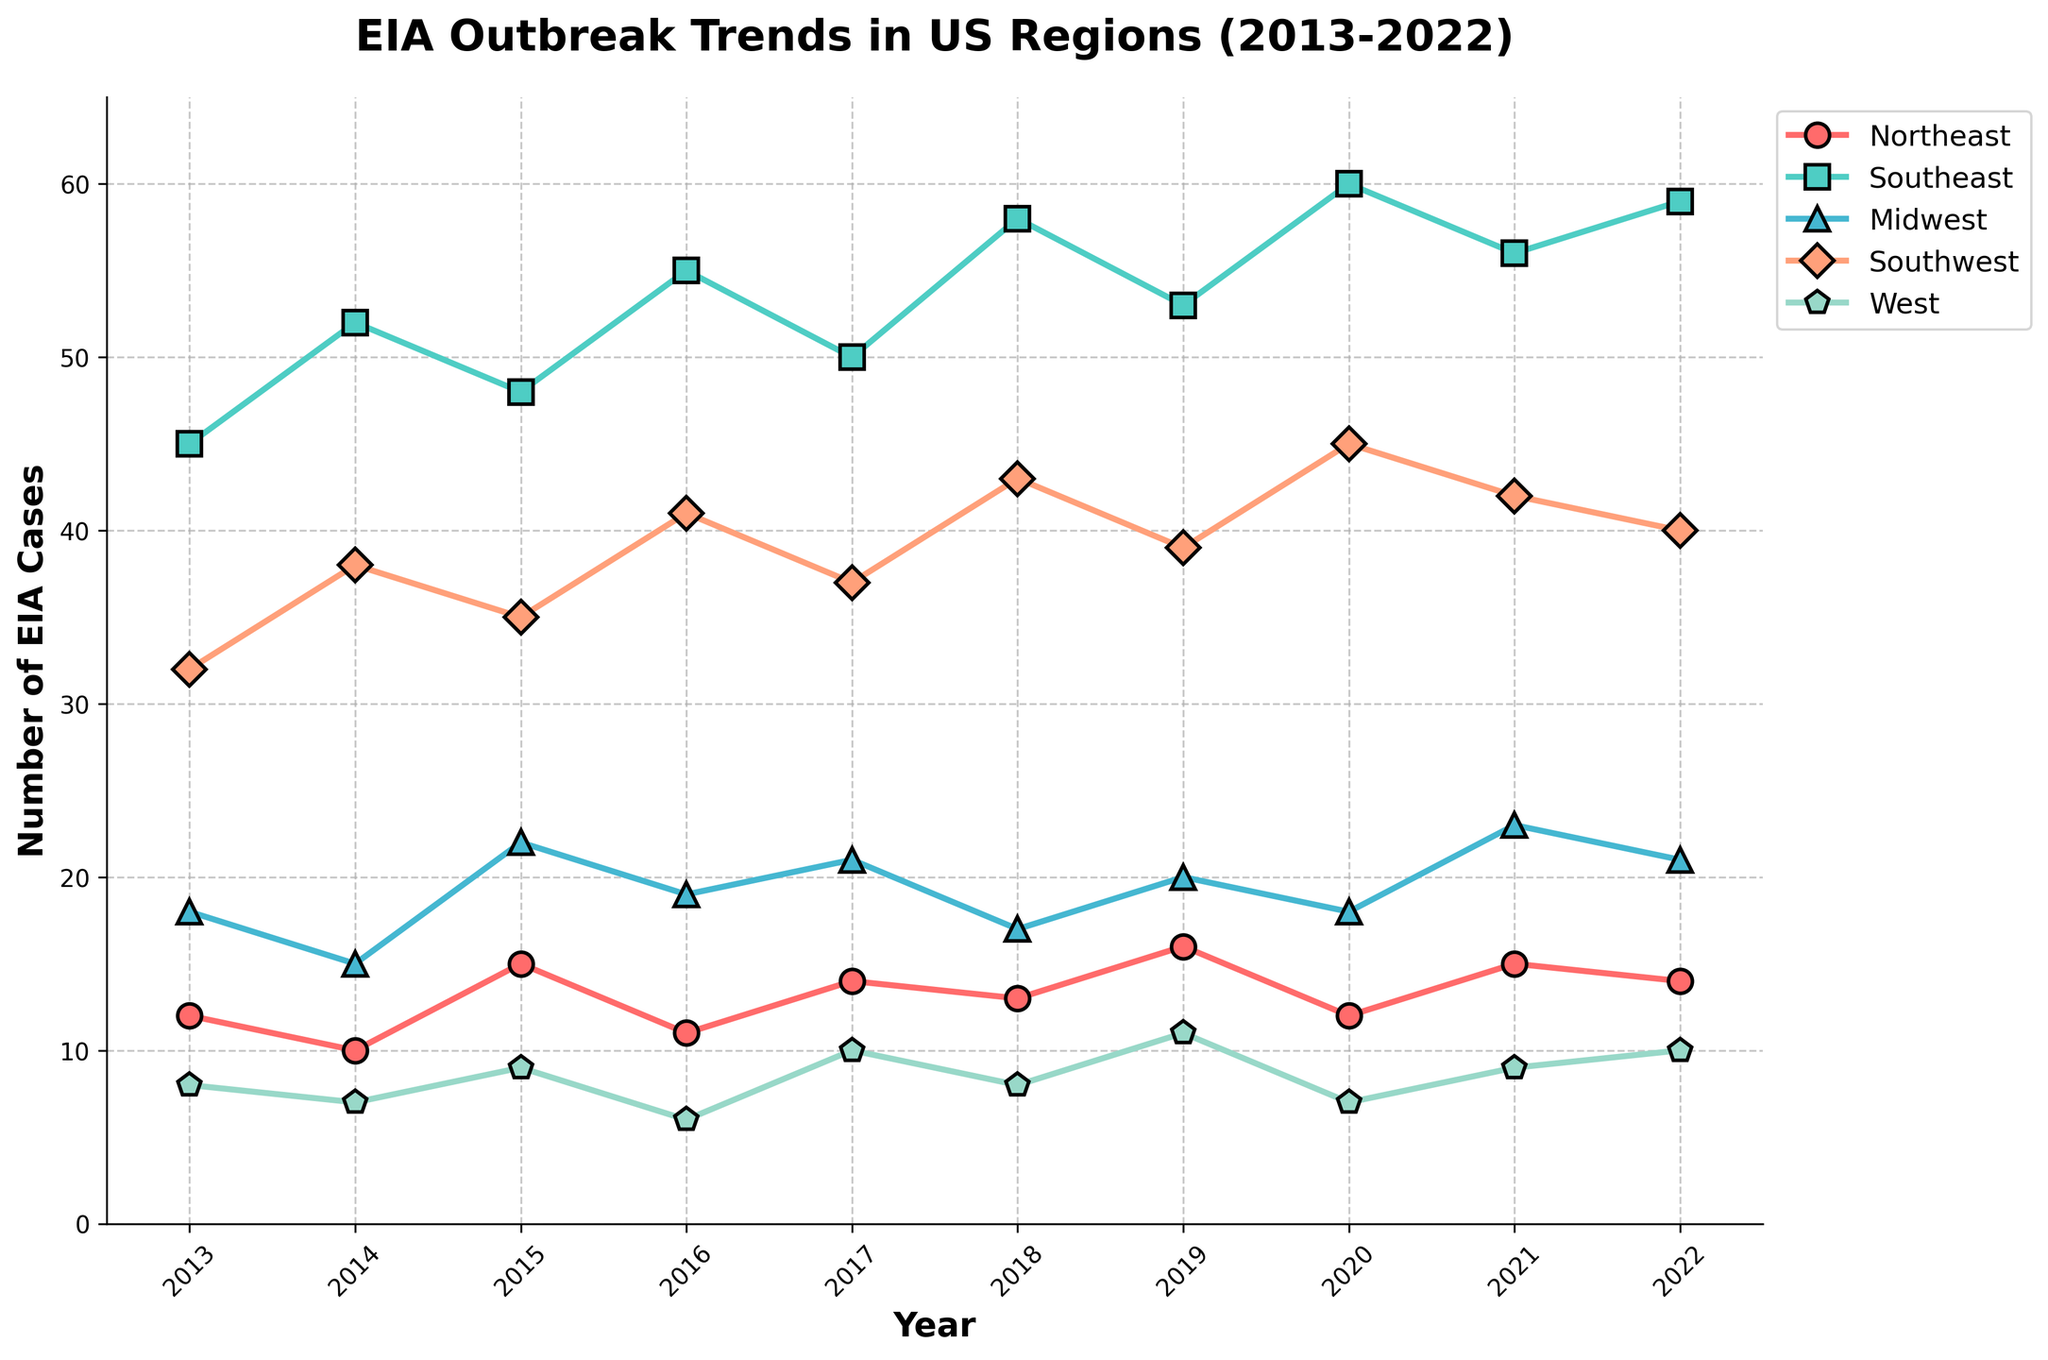How many EIA cases were reported in the Midwest and West in 2015 combined? According to the chart, the number of EIA cases in the Midwest in 2015 was 22, and in the West, it was 9. To find the combined number, add 22 and 9, which results in 31.
Answer: 31 Which region had the largest increase in EIA cases from 2019 to 2020? From the figure, the number of EIA cases in each region in 2019 and 2020 are as follows: Northeast (16 to 12), Southeast (53 to 60), Midwest (20 to 18), Southwest (39 to 45), and West (11 to 7). The Southeast showed the highest increase in cases from 53 to 60, an increase of 7 cases.
Answer: Southeast Considering the year 2014, which region had the second-highest number of EIA cases? In 2014, the number of EIA cases by region were: Northeast (10), Southeast (52), Midwest (15), Southwest (38), and West (7). The Southeast had the highest with 52 cases, and the Southwest had the second highest with 38 cases.
Answer: Southwest What was the average number of EIA cases in the Southeast over the entire period shown on the chart? To find the average number of EIA cases in the Southeast from 2013 to 2022, add the numbers: 45 + 52 + 48 + 55 + 50 + 58 + 53 + 60 + 56 + 59 = 536. Then divide by the number of years, which is 10. The average is 536 / 10 = 53.6 cases per year.
Answer: 53.6 Which year had the lowest total number of EIA cases across all regions? To determine the year with the lowest total number of EIA cases, sum the cases for each year and compare: 2013 (115), 2014 (122), 2015 (129), 2016 (132), 2017 (132), 2018 (139), 2019 (139), 2020 (142), 2021 (145), 2022 (144). The lowest total is in 2013 with 115 cases.
Answer: 2013 In which year did the Northeast experience the highest number of EIA cases? By examining the Northeast data points across the years, the number of EIA cases in various years are: 2013 (12), 2014 (10), 2015 (15), 2016 (11), 2017 (14), 2018 (13), 2019 (16), 2020 (12), 2021 (15), 2022 (14). The highest was in 2019 with 16 cases.
Answer: 2019 For the year 2021, did the Midwest report more EIA cases than the Southwest? In 2021, according to the chart, the Midwest had 23 EIA cases and the Southwest had 42 EIA cases. Comparatively, the Midwest had fewer cases than the Southwest.
Answer: No What is the trend observed in the number of EIA cases in the Southeast from 2017 to 2020? Examining the data for the Southeast, the number of EIA cases are: 2017 (50), 2018 (58), 2019 (53), 2020 (60). The trend shows a general increase with a slight dip in 2019 before rising again in 2020.
Answer: Increasing trend How many years did the West region report fewer than 10 EIA cases? Looking at the data points for the West region: 2013 (8), 2014 (7), 2015 (9), 2016 (6), 2017 (10), 2018 (8), 2019 (11), 2020 (7), 2021 (9), 2022 (10), the West reported fewer than 10 cases in 7 years.
Answer: 7 